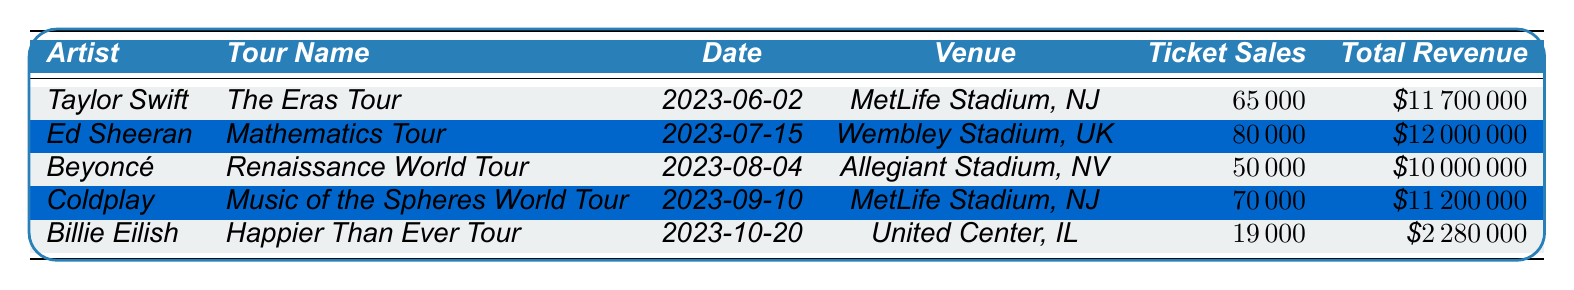What artist had the highest total revenue? By examining the total revenue column, the values are: Taylor Swift - $11,700,000, Ed Sheeran - $12,000,000, Beyoncé - $10,000,000, Coldplay - $11,200,000, and Billie Eilish - $2,280,000. Ed Sheeran has the highest revenue at $12,000,000.
Answer: Ed Sheeran What is the total ticket sales for all the artists combined? The ticket sales for each artist are: Taylor Swift - 65,000, Ed Sheeran - 80,000, Beyoncé - 50,000, Coldplay - 70,000, Billie Eilish - 19,000. Adding these values gives: 65,000 + 80,000 + 50,000 + 70,000 + 19,000 = 284,000.
Answer: 284,000 Did Beyoncé's tour have higher ticket sales than Billie Eilish's tour? Beyoncé sold 50,000 tickets while Billie Eilish sold 19,000 tickets. Comparing these figures shows that 50,000 is greater than 19,000, confirming that Beyoncé's tour had higher ticket sales.
Answer: Yes Which tour had the lowest average ticket price, and what was that price? The average prices are: Taylor Swift - $180, Ed Sheeran - $150, Beyoncé - $200, Coldplay - $160, Billie Eilish - $120. The lowest average price is $120 for Billie Eilish's tour.
Answer: Billie Eilish - $120 What is the difference in total revenue between Ed Sheeran and Coldplay? Ed Sheeran's total revenue is $12,000,000 and Coldplay's revenue is $11,200,000. The difference is calculated as $12,000,000 - $11,200,000 = $800,000.
Answer: $800,000 What percentage of total revenue came from Taylor Swift's tour compared to the total revenue from all tours? Taylor Swift's total revenue is $11,700,000. The total revenue for all artists is $12,000,000 + $11,700,000 + $10,000,000 + $11,200,000 + $2,280,000 = $57,180,000. The percentage is calculated as ($11,700,000 / $57,180,000) * 100 ≈ 20.5%.
Answer: 20.5% How many ticket sales does Coldplay have compared to the average ticket sales of all artists? Coldplay sold 70,000 tickets. The average ticket sales of all artists is calculated as (65,000 + 80,000 + 50,000 + 70,000 + 19,000) / 5 = 56,000. Comparing shows that 70,000 > 56,000.
Answer: More than average Which artist had the least ticket sales, and how many were sold? The ticket sales for each artist are: Taylor Swift - 65,000, Ed Sheeran - 80,000, Beyoncé - 50,000, Coldplay - 70,000, Billie Eilish - 19,000. Billie Eilish has the least ticket sales at 19,000.
Answer: Billie Eilish - 19,000 Did any artist achieve total revenue over $10,000,000? The total revenues are: Taylor Swift - $11,700,000, Ed Sheeran - $12,000,000, Beyoncé - $10,000,000, Coldplay - $11,200,000, Billie Eilish - $2,280,000. Checking these values shows that all except Billie Eilish exceeded $10,000,000.
Answer: Yes 